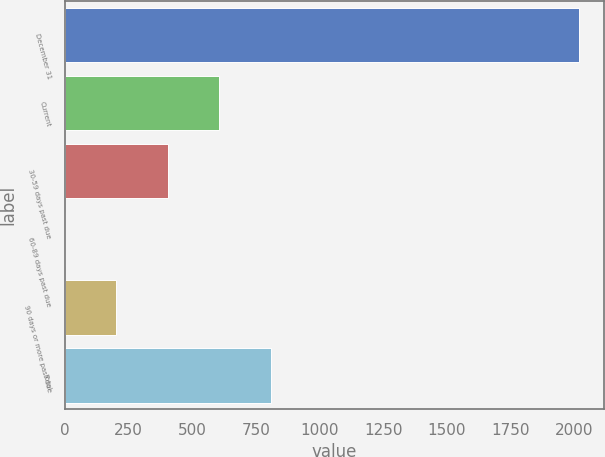Convert chart. <chart><loc_0><loc_0><loc_500><loc_500><bar_chart><fcel>December 31<fcel>Current<fcel>30-59 days past due<fcel>60-89 days past due<fcel>90 days or more past due<fcel>Total<nl><fcel>2017<fcel>605.73<fcel>404.12<fcel>0.9<fcel>202.51<fcel>807.34<nl></chart> 